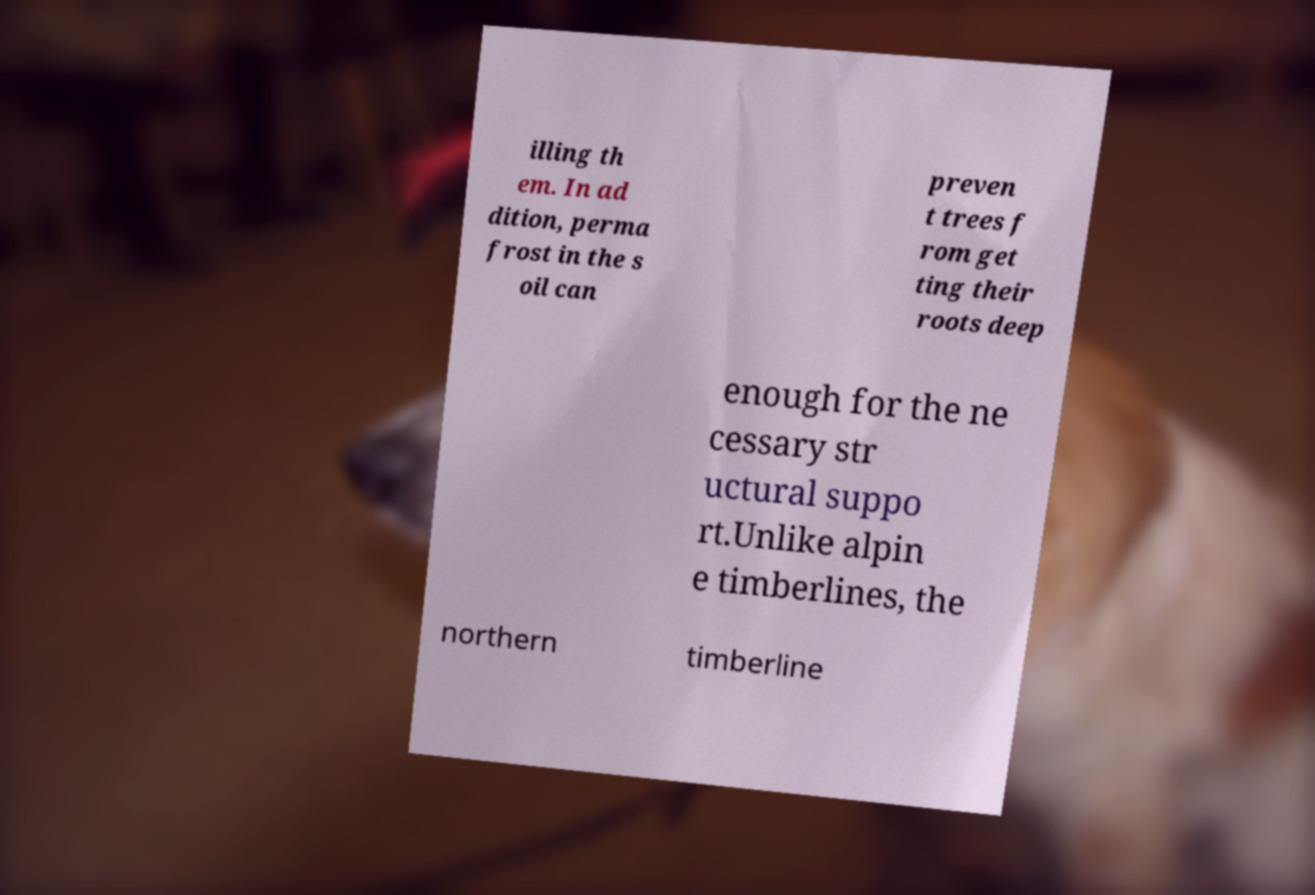Could you assist in decoding the text presented in this image and type it out clearly? illing th em. In ad dition, perma frost in the s oil can preven t trees f rom get ting their roots deep enough for the ne cessary str uctural suppo rt.Unlike alpin e timberlines, the northern timberline 